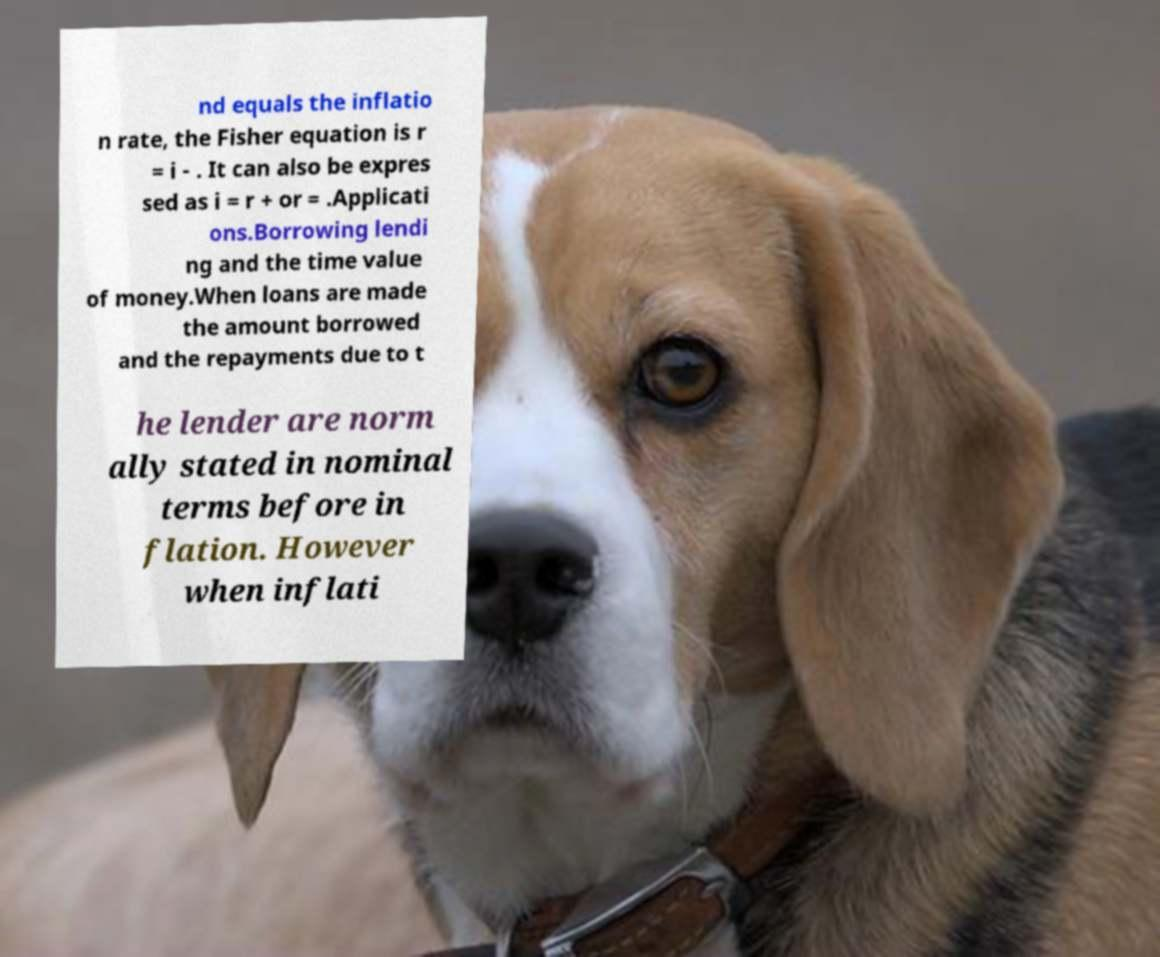What messages or text are displayed in this image? I need them in a readable, typed format. nd equals the inflatio n rate, the Fisher equation is r = i - . It can also be expres sed as i = r + or = .Applicati ons.Borrowing lendi ng and the time value of money.When loans are made the amount borrowed and the repayments due to t he lender are norm ally stated in nominal terms before in flation. However when inflati 